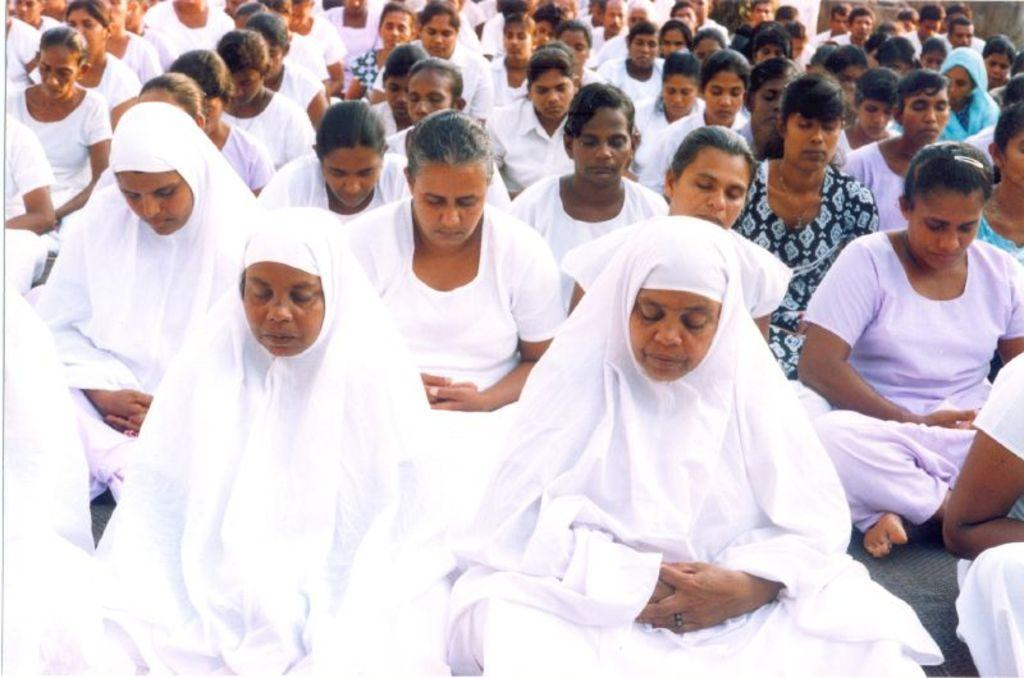What is happening in the image? There is a group of people in the image, and they are sitting. What are the people doing while sitting? The people have their eyes closed. What can be observed about the clothing of some people in the image? Some of the people are wearing white color clothes. What type of apparatus is being used by the beggar in the image? There is no beggar or apparatus present in the image. What range of emotions can be seen on the faces of the people in the image? The image does not show the faces of the people, so it is not possible to determine their range of emotions. 